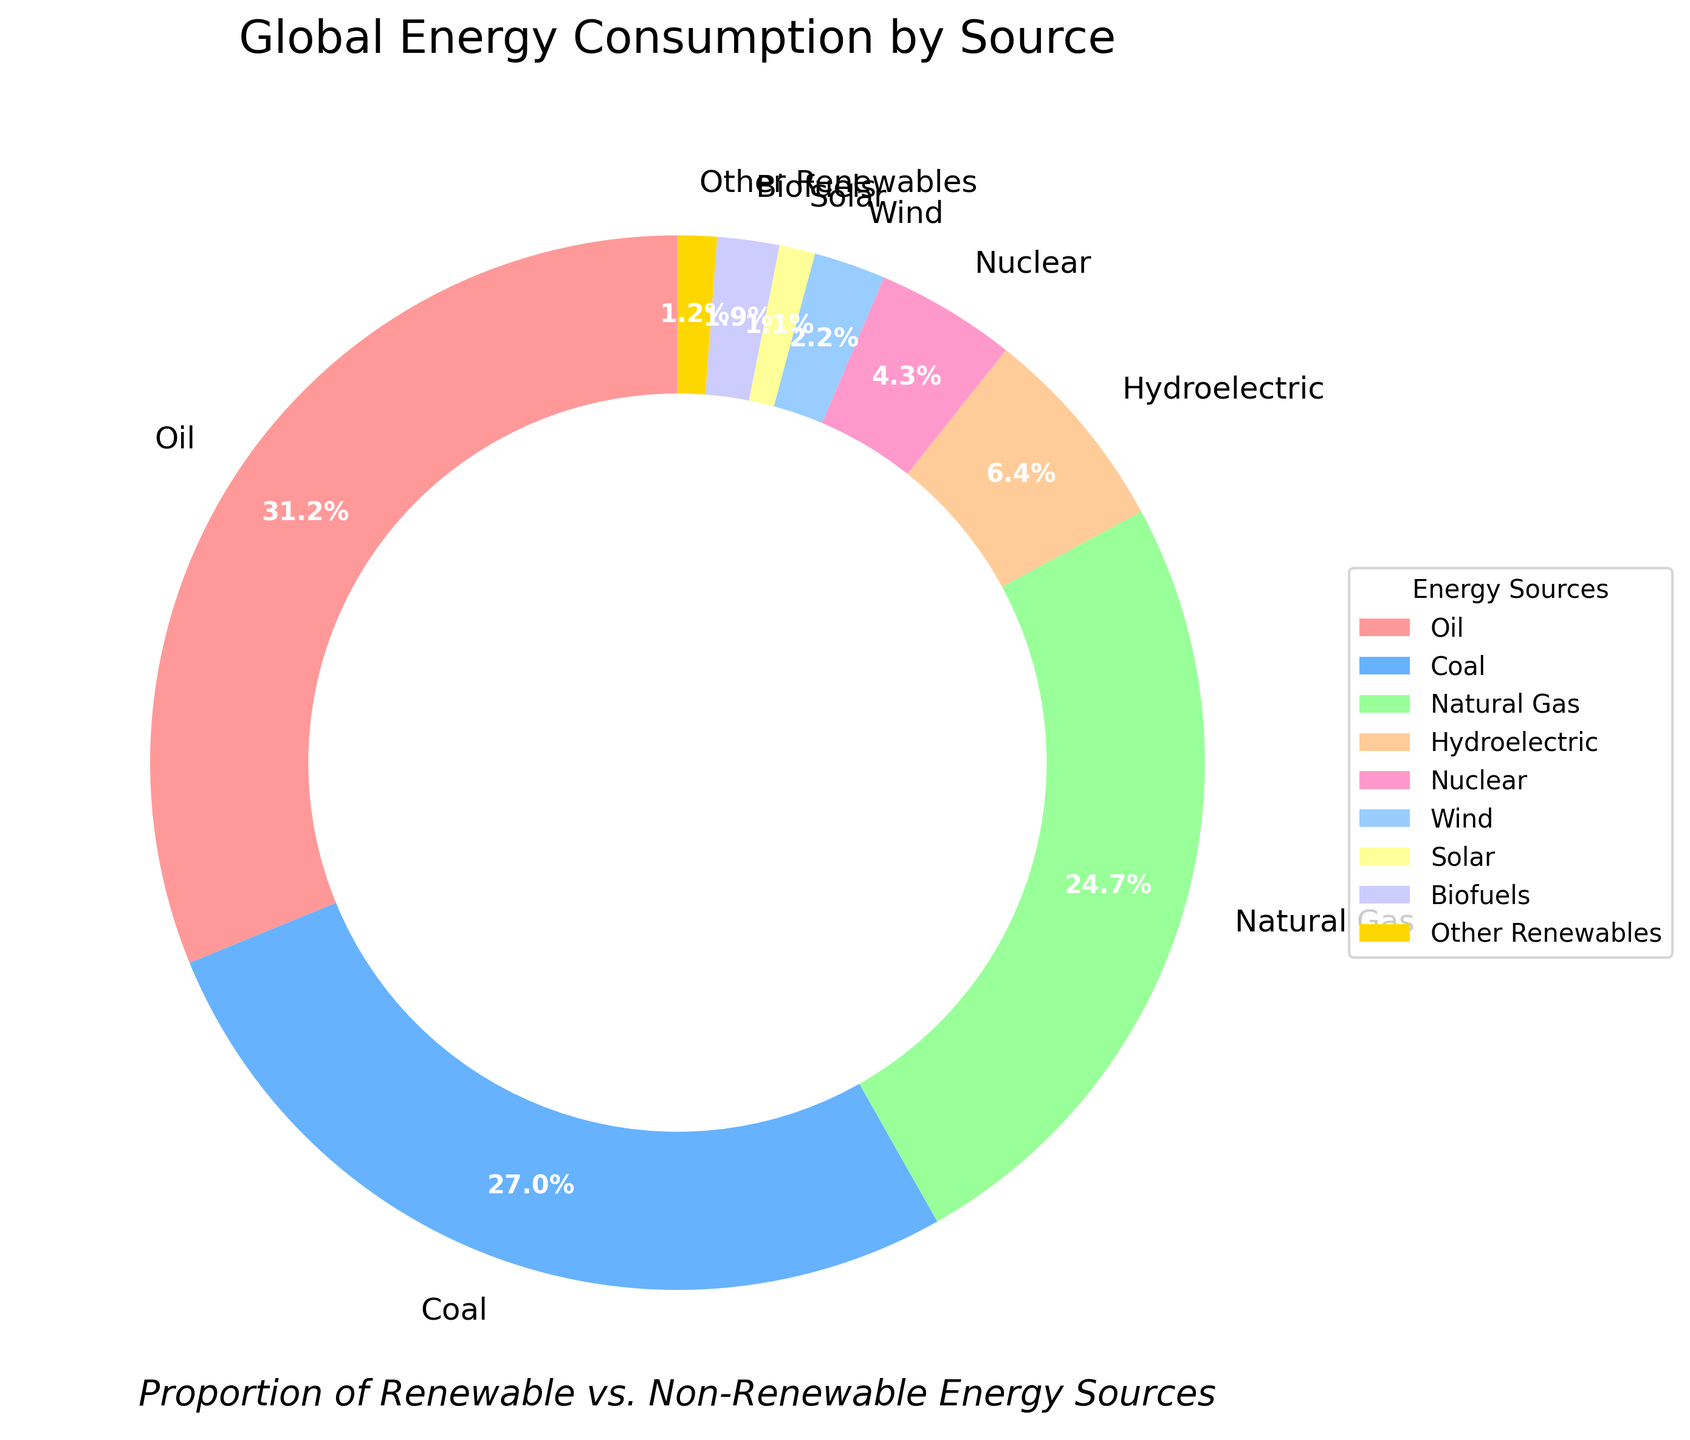Which energy source has the highest percentage in global energy consumption? The pie chart shows that Oil has the largest section with a percentage of 31.2%, making it the highest.
Answer: Oil What is the combined percentage of coal and natural gas in global energy consumption? Coal has a percentage of 27.0% and Natural Gas has 24.7%. Adding these together, 27.0 + 24.7 = 51.7%.
Answer: 51.7% Which renewable energy source has the largest percentage in the global energy consumption? Among the renewable energy sources listed (Hydroelectric, Wind, Solar, Biofuels, Other Renewables), Hydroelectric has the largest percentage at 6.4%.
Answer: Hydroelectric How does the percentage of Wind compare to Solar energy? The chart shows Wind with 2.2% and Solar with 1.1%. Since 2.2% is greater than 1.1%, Wind has the higher percentage.
Answer: Wind is higher Are there any energy sources that have a smaller percentage than Biofuels in the global energy consumption? Biofuels have 1.9%. The only other categories with smaller percentages are Solar with 1.1% and Other Renewables with 1.2%.
Answer: Yes, Solar and Other Renewables What proportion of global energy consumption is renewable? Adding up the percentages for Hydroelectric (6.4%), Wind (2.2%), Solar (1.1%), Biofuels (1.9%), and Other Renewables (1.2%), the total is 6.4 + 2.2 + 1.1 + 1.9 + 1.2 = 12.8%.
Answer: 12.8% Is the percentage of Nuclear energy greater than any of the renewable sources? Nuclear energy is at 4.3%. All renewable sources individually are Hydroelectric (6.4%), Wind (2.2%), Solar (1.1%), Biofuels (1.9%), and Other Renewables (1.2%). Only Hydroelectric exceeds Nuclear, so Nuclear is greater than Wind, Solar, Biofuels, and Other Renewables.
Answer: Yes, greater than Wind, Solar, Biofuels, and Other Renewables Which energy sources combined form less than 10% of global energy consumption? The chart shows Wind (2.2%), Solar (1.1%), Biofuels (1.9%), and Other Renewables (1.2%). Adding them gives 2.2 + 1.1 + 1.9 + 1.2 = 6.4%. These combined are below 10%.
Answer: Wind, Solar, Biofuels, Other Renewables 